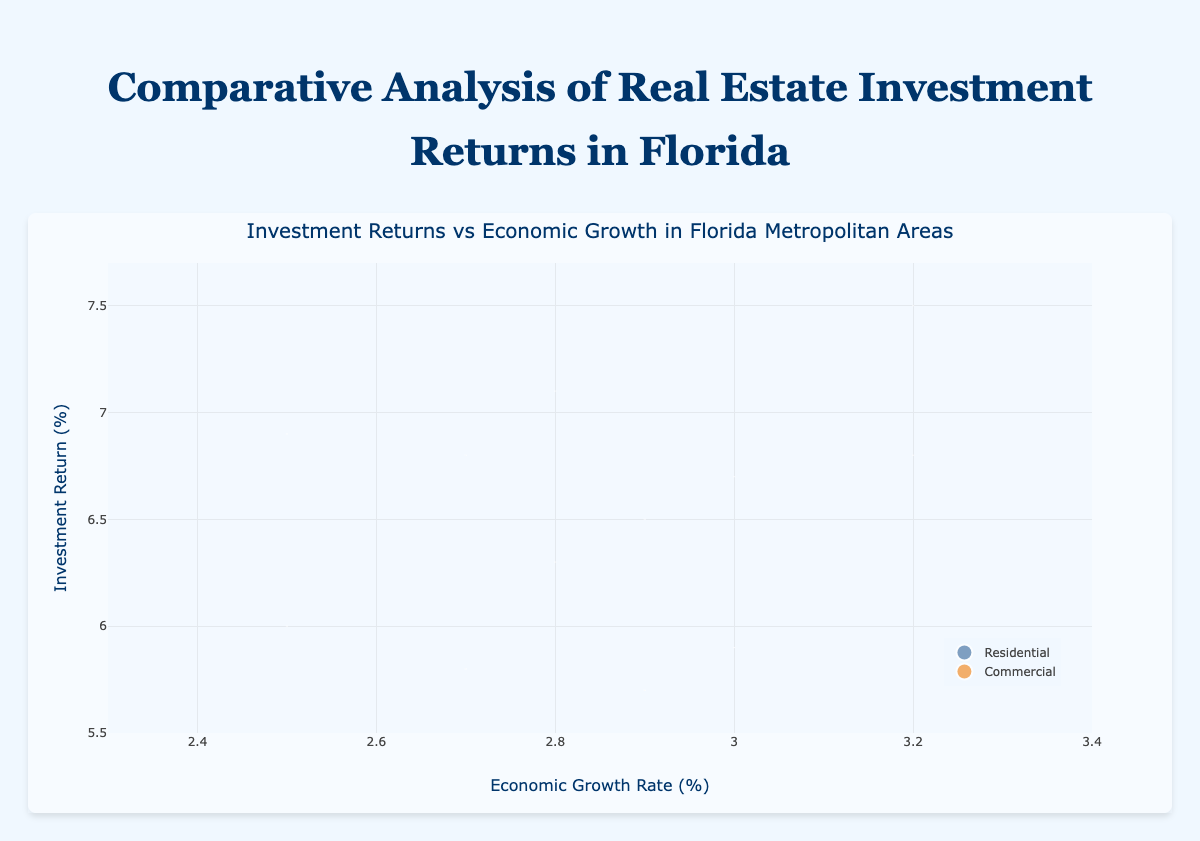How many data points are presented for each property type? There are 12 data points in total, 6 for Residential and 6 for Commercial based on the different locations shown.
Answer: 6 each Which metropolitan area shows the highest investment return for Residential properties? By looking at the y-axis values for the Residential bubbles, Miami has the highest investment return at 7.5%.
Answer: Miami What's the difference in investment returns between Residential and Commercial properties in Jacksonville? The investment return for Residential properties in Jacksonville is 6.9%, and for Commercial properties, it is 6.0%. The difference is 6.9% - 6.0% = 0.9%.
Answer: 0.9% For which property type are the bubble sizes generally larger? Comparing the sizes of the bubbles for Residential and Commercial properties, Commercial properties generally have larger bubble sizes.
Answer: Commercial Which location has the highest economic growth rate? The x-axis represents the economic growth rate, and the highest rate is 3.2%, seen in Miami.
Answer: Miami Which location has the smallest bubble for Residential properties? By comparing the sizes of all Residential property bubbles, Jacksonville has the smallest bubble size, which is 1700000.
Answer: Jacksonville Compare the investment returns of Residential properties between Orlando and Fort Lauderdale. Which one is higher? The investment return for Residential properties in Orlando is 6.7%, and in Fort Lauderdale, it is 6.5%. Orlando's investment return is higher.
Answer: Orlando What's the median economic growth rate among all the locations? The economic growth rates are 3.2, 3.0, 2.8, 2.5, 2.9, and 2.7. Arranging them in order: 2.5, 2.7, 2.8, 2.9, 3.0, 3.2. The median is the average of the third and fourth values: (2.8 + 2.9) / 2 = 2.85.
Answer: 2.85 Where do Commercial properties provide a lower return than Residential properties, and by how much? In all locations (Miami, Orlando, Tampa, Jacksonville, Fort Lauderdale, St. Petersburg), Residential properties have higher returns. For example, in Miami, the difference is 7.5% - 6.8% = 0.7%. Similar calculations for other locations also show positive differences.
Answer: All locations, varies 